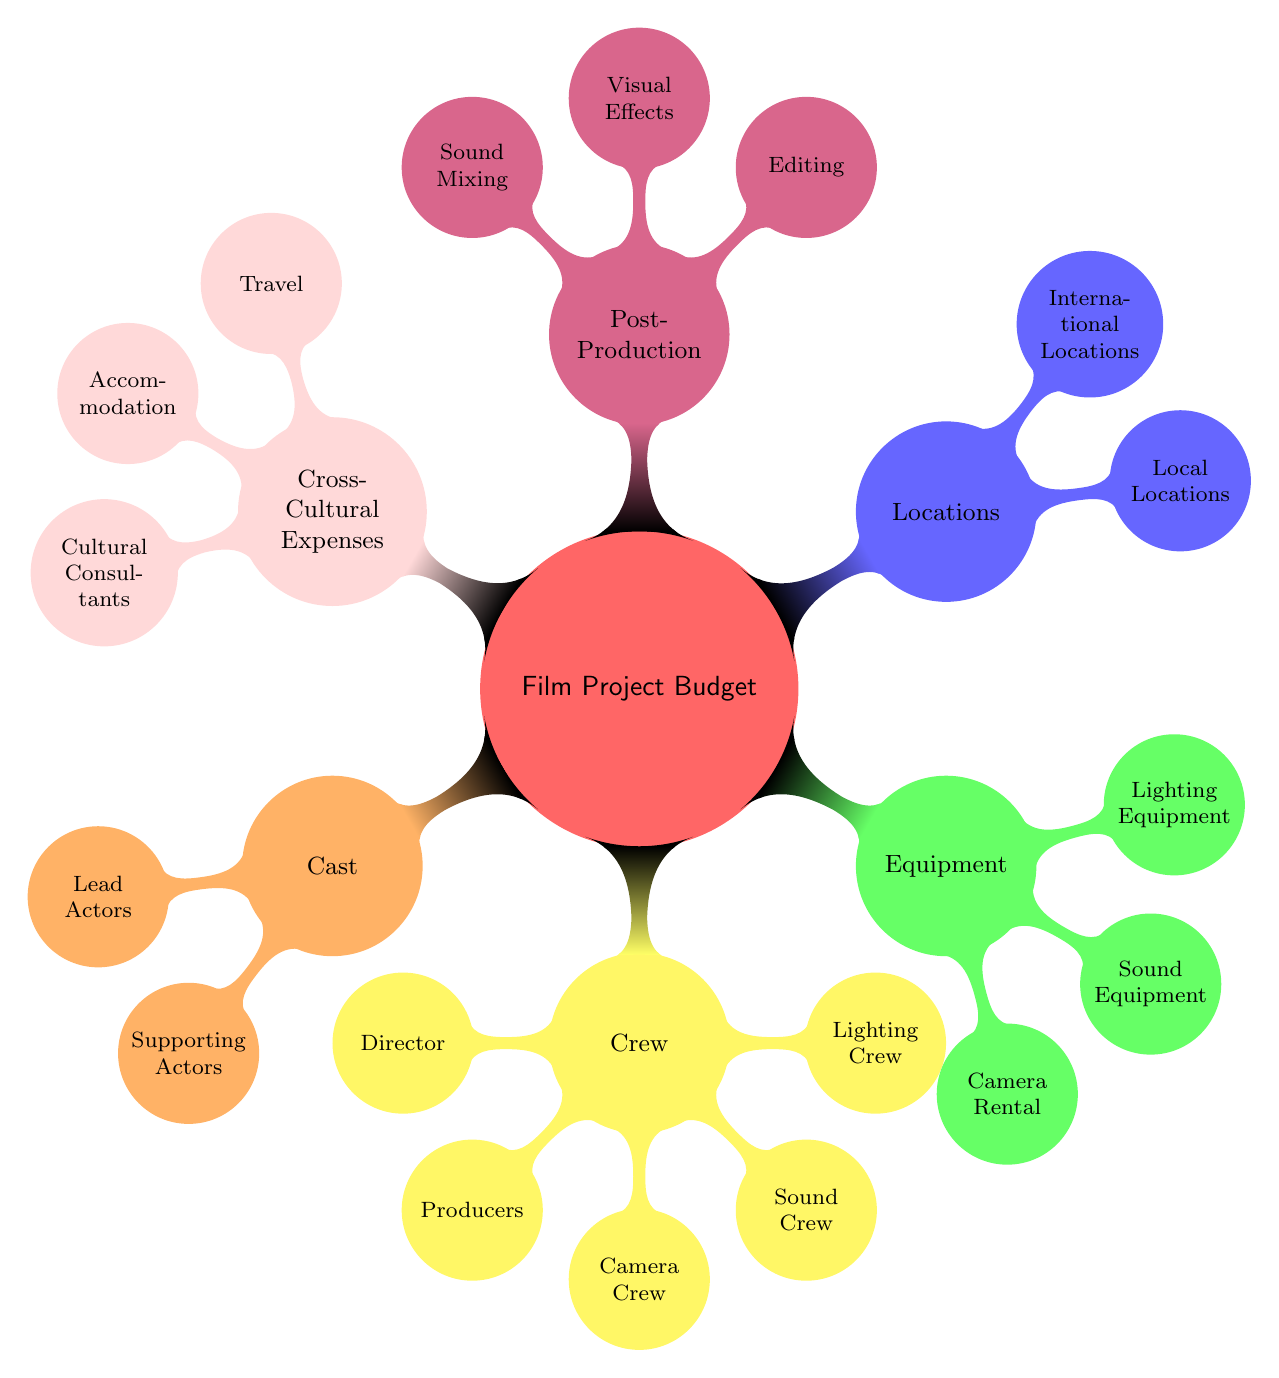What are the two main categories under cast? The diagram shows two child nodes under the Cast category: Lead Actors and Supporting Actors.
Answer: Lead Actors, Supporting Actors How many components are listed under crew? The Crew category consists of five components: Director, Producers, Camera Crew, Sound Crew, and Lighting Crew. Counting these gives a total of 5 nodes.
Answer: 5 What colors represent the locations in the diagram? The Locations category is represented in blue, which distinctly identifies it from other categories.
Answer: Blue Which section specifically deals with cross-cultural production expenses? The Cross-Cultural Expenses section is dedicated to costs associated with cross-cultural productions. It includes Travel, Accommodation, and Cultural Consultants.
Answer: Cross-Cultural Expenses What are the three elements listed under post-production? Under the Post-Production category, the elements listed are Editing, Visual Effects, and Sound Mixing. This provides a summary of the key tasks involved in this phase.
Answer: Editing, Visual Effects, Sound Mixing What is the relation between equipment and the specific items listed beneath it? The Equipment category includes Camera Rental, Sound Equipment, and Lighting Equipment, indicating that these are essential items for the overall production.
Answer: Camera Rental, Sound Equipment, Lighting Equipment How does the diagram organize expenses for travel related to cross-cultural production? The Cross-Cultural Expenses node has a child node named Travel, indicating that it specifically addresses travel expenses related to cross-cultural projects.
Answer: Travel What is the purpose of cultural consultants in the budget? Cultural Consultants fall under Cross-Cultural Expenses, highlighting their role in ensuring cultural sensitivity and authenticity in the production process.
Answer: Cultural Consultants 